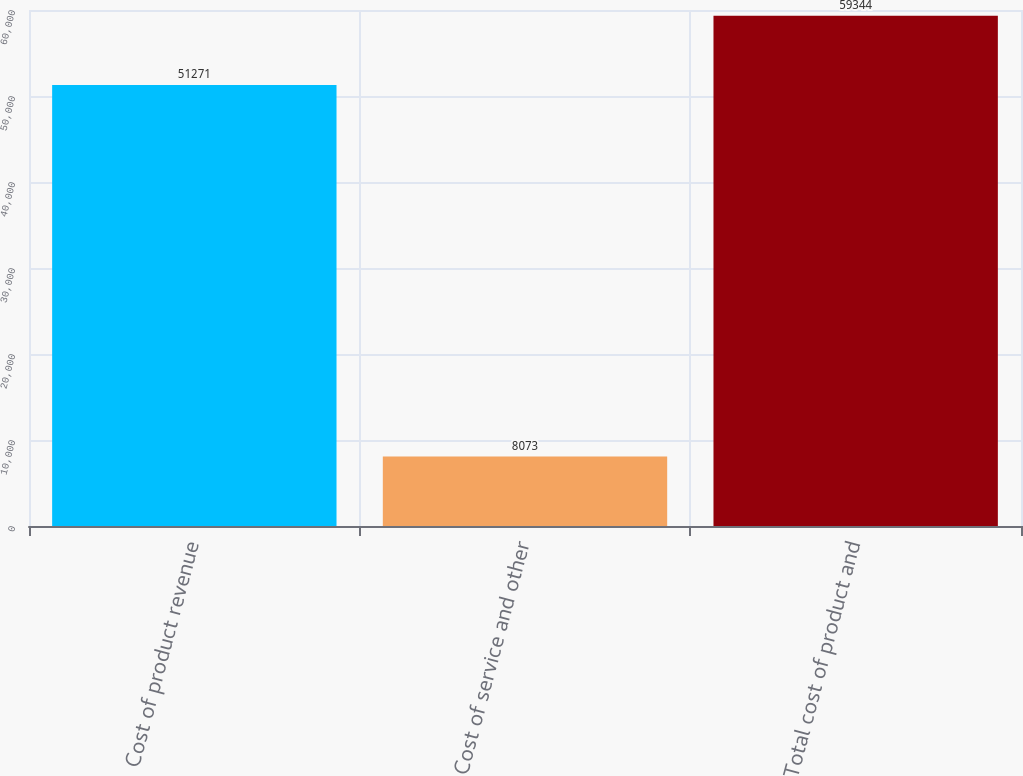Convert chart. <chart><loc_0><loc_0><loc_500><loc_500><bar_chart><fcel>Cost of product revenue<fcel>Cost of service and other<fcel>Total cost of product and<nl><fcel>51271<fcel>8073<fcel>59344<nl></chart> 